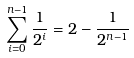<formula> <loc_0><loc_0><loc_500><loc_500>\sum _ { i = 0 } ^ { n - 1 } { \frac { 1 } { 2 ^ { i } } } = 2 - { \frac { 1 } { 2 ^ { n - 1 } } }</formula> 